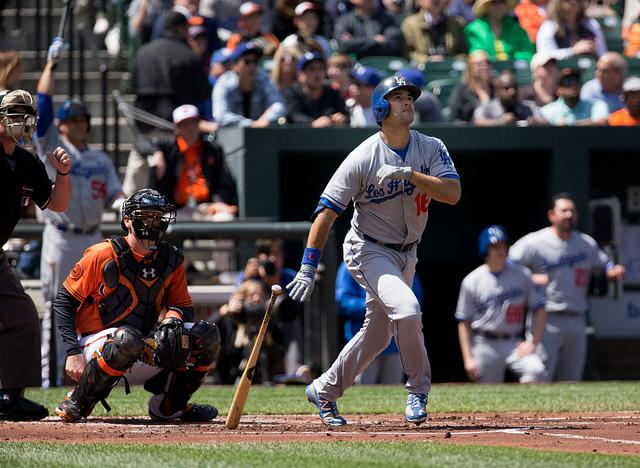The player just hit the ball so he watches it while he runs to what base? first 